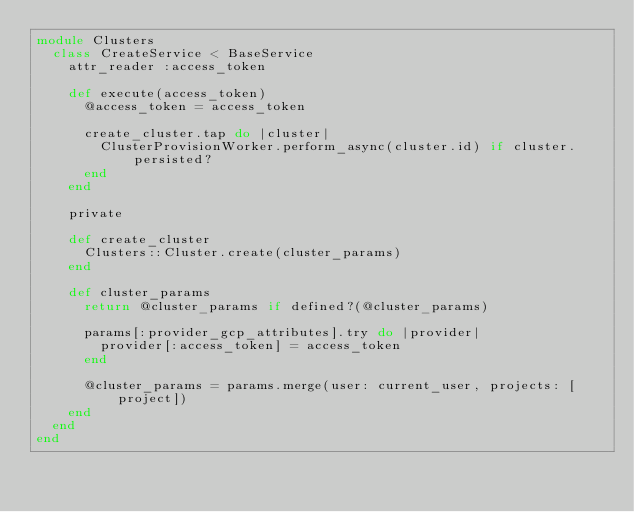<code> <loc_0><loc_0><loc_500><loc_500><_Ruby_>module Clusters
  class CreateService < BaseService
    attr_reader :access_token

    def execute(access_token)
      @access_token = access_token

      create_cluster.tap do |cluster|
        ClusterProvisionWorker.perform_async(cluster.id) if cluster.persisted?
      end
    end

    private

    def create_cluster
      Clusters::Cluster.create(cluster_params)
    end

    def cluster_params
      return @cluster_params if defined?(@cluster_params)

      params[:provider_gcp_attributes].try do |provider|
        provider[:access_token] = access_token
      end

      @cluster_params = params.merge(user: current_user, projects: [project])
    end
  end
end
</code> 